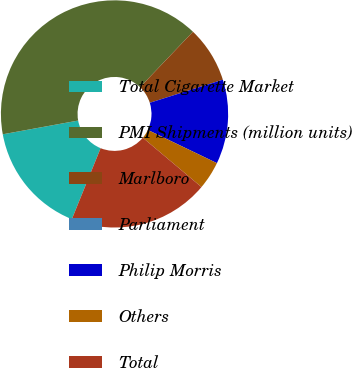Convert chart. <chart><loc_0><loc_0><loc_500><loc_500><pie_chart><fcel>Total Cigarette Market<fcel>PMI Shipments (million units)<fcel>Marlboro<fcel>Parliament<fcel>Philip Morris<fcel>Others<fcel>Total<nl><fcel>16.0%<fcel>40.0%<fcel>8.0%<fcel>0.0%<fcel>12.0%<fcel>4.0%<fcel>20.0%<nl></chart> 